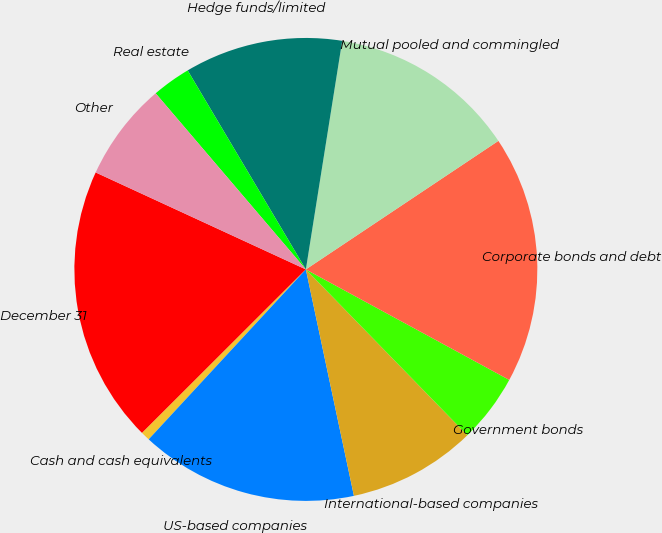<chart> <loc_0><loc_0><loc_500><loc_500><pie_chart><fcel>December 31<fcel>Cash and cash equivalents<fcel>US-based companies<fcel>International-based companies<fcel>Government bonds<fcel>Corporate bonds and debt<fcel>Mutual pooled and commingled<fcel>Hedge funds/limited<fcel>Real estate<fcel>Other<nl><fcel>19.37%<fcel>0.63%<fcel>15.21%<fcel>8.96%<fcel>4.79%<fcel>17.29%<fcel>13.12%<fcel>11.04%<fcel>2.71%<fcel>6.88%<nl></chart> 